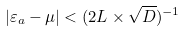<formula> <loc_0><loc_0><loc_500><loc_500>| \varepsilon _ { a } - \mu | < ( 2 L \times \sqrt { D } ) ^ { - 1 }</formula> 